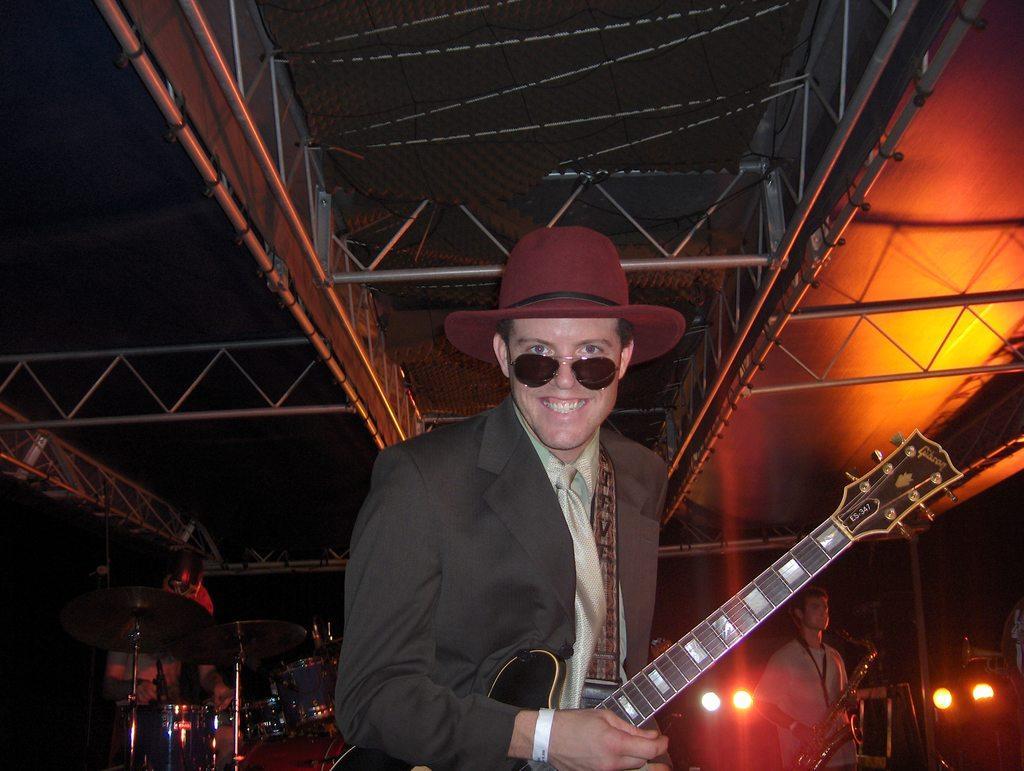In one or two sentences, can you explain what this image depicts? In this picture there is a man standing holding the guitar and smiling wearing a hat and another person standing here holding the saxophone there is also drum sent behind 